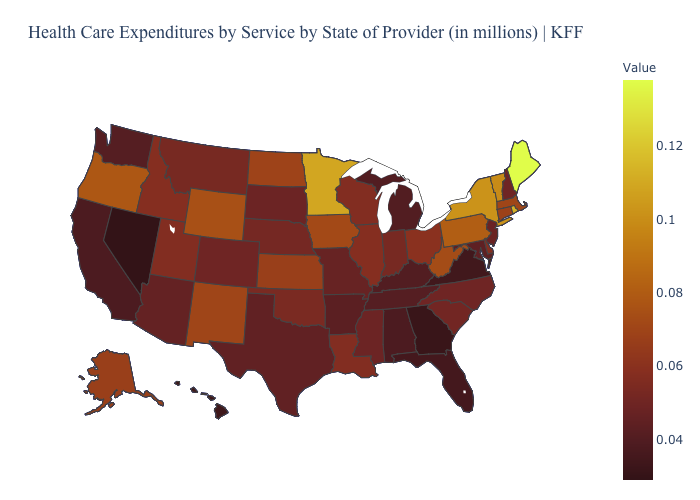Does the map have missing data?
Short answer required. No. Does Idaho have the lowest value in the West?
Write a very short answer. No. 